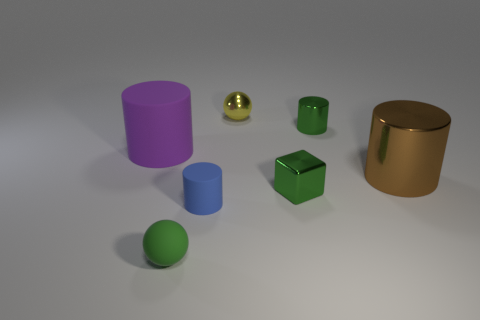The sphere that is the same color as the cube is what size?
Keep it short and to the point. Small. Is the material of the tiny cube the same as the green cylinder?
Your answer should be compact. Yes. What number of small green rubber objects are the same shape as the tiny blue object?
Make the answer very short. 0. There is a small yellow object that is made of the same material as the large brown thing; what shape is it?
Make the answer very short. Sphere. There is a large thing that is behind the metallic cylinder that is in front of the big purple object; what is its color?
Make the answer very short. Purple. Is the block the same color as the tiny metal cylinder?
Provide a succinct answer. Yes. What is the material of the tiny cylinder that is in front of the large cylinder in front of the big purple thing?
Offer a very short reply. Rubber. What is the material of the blue thing that is the same shape as the large purple object?
Make the answer very short. Rubber. There is a green thing behind the rubber thing behind the brown shiny thing; are there any tiny metallic blocks behind it?
Keep it short and to the point. No. How many other objects are there of the same color as the small rubber sphere?
Provide a short and direct response. 2. 